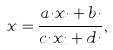<formula> <loc_0><loc_0><loc_500><loc_500>x = \frac { a _ { i } x _ { i } + b _ { i } } { c _ { i } x _ { i } + d _ { i } } ,</formula> 